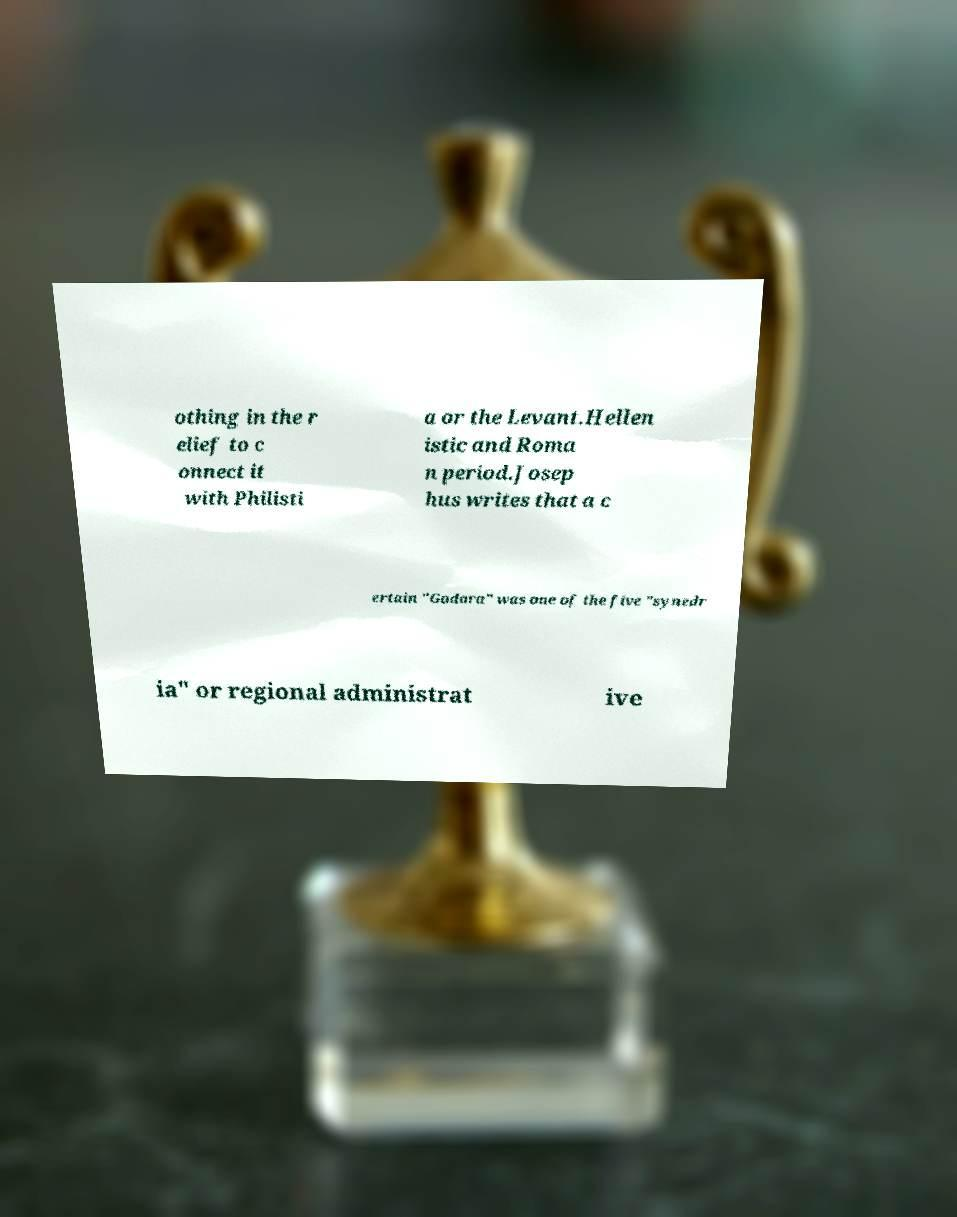I need the written content from this picture converted into text. Can you do that? othing in the r elief to c onnect it with Philisti a or the Levant.Hellen istic and Roma n period.Josep hus writes that a c ertain "Gadara" was one of the five "synedr ia" or regional administrat ive 